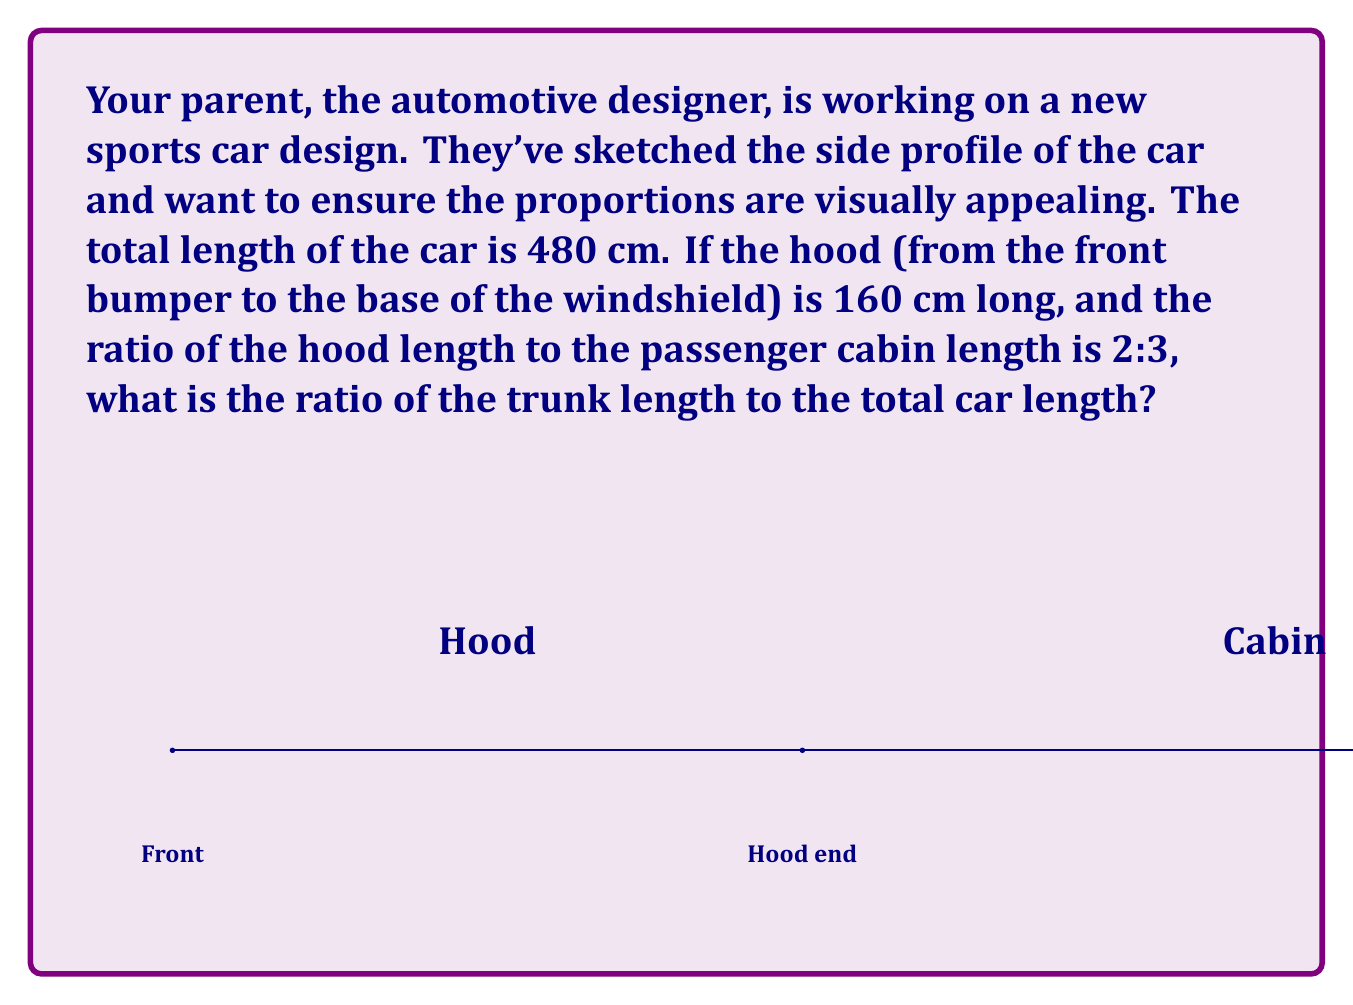Help me with this question. Let's approach this step-by-step:

1) First, let's identify the known information:
   - Total car length = 480 cm
   - Hood length = 160 cm
   - Ratio of hood length to cabin length = 2:3

2) Let's find the cabin length:
   If hood : cabin = 2 : 3, and hood = 160 cm, then:
   $$\frac{160}{2} = \frac{\text{cabin}}{3}$$
   $$80 = \frac{\text{cabin}}{3}$$
   $$\text{cabin} = 80 \times 3 = 240 \text{ cm}$$

3) Now we can calculate the trunk length:
   $$\text{trunk} = \text{total length} - (\text{hood} + \text{cabin})$$
   $$\text{trunk} = 480 - (160 + 240) = 80 \text{ cm}$$

4) To find the ratio of trunk length to total car length, we divide both by their greatest common divisor (GCD):
   $$\frac{\text{trunk}}{\text{total length}} = \frac{80}{480} = \frac{1}{6}$$

5) Therefore, the ratio of trunk length to total car length is 1:6.
Answer: 1:6 